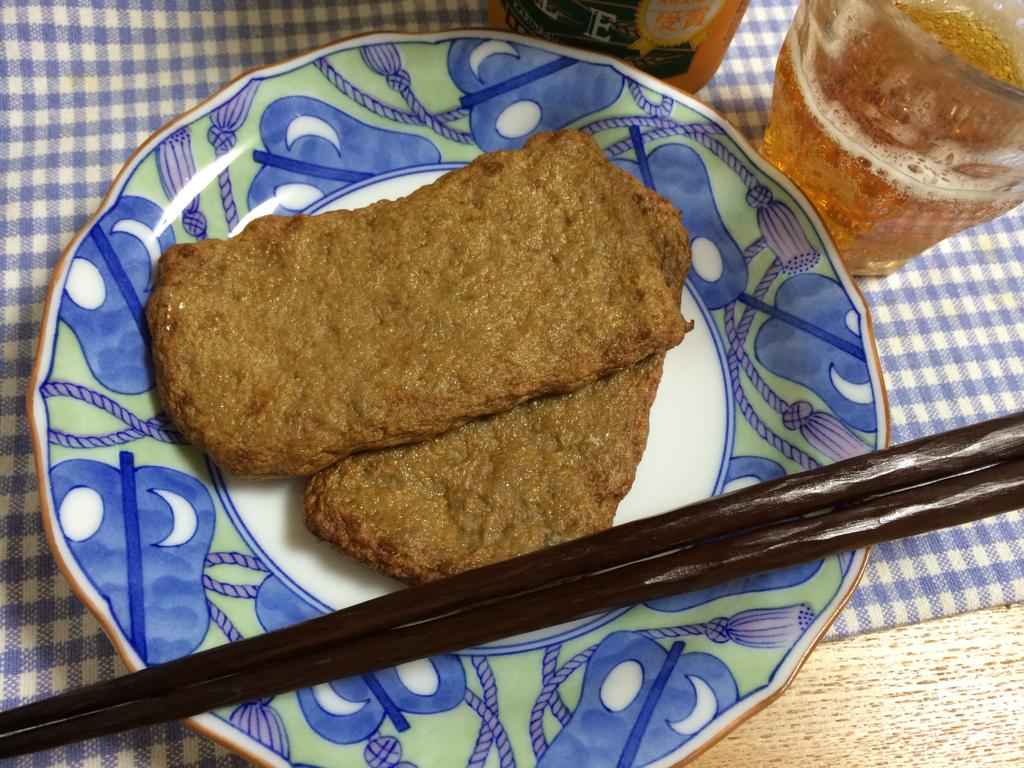What is the main food item served in the image? There is a cooked food item served in a plate in the image. What utensils are provided for eating the food? There are two chopsticks beside the plate in the image. What beverage is served alongside the food? There is a drink poured in a glass beside the plate in the image. How does the tent contribute to the growth of the food in the image? There is no tent present in the image, so it cannot contribute to the growth of the food. 